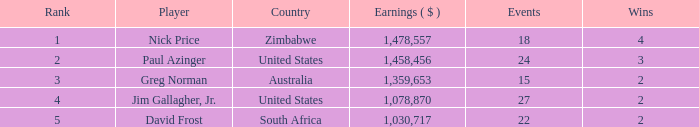How many events have earnings less than 1,030,717? 0.0. Give me the full table as a dictionary. {'header': ['Rank', 'Player', 'Country', 'Earnings ( $ )', 'Events', 'Wins'], 'rows': [['1', 'Nick Price', 'Zimbabwe', '1,478,557', '18', '4'], ['2', 'Paul Azinger', 'United States', '1,458,456', '24', '3'], ['3', 'Greg Norman', 'Australia', '1,359,653', '15', '2'], ['4', 'Jim Gallagher, Jr.', 'United States', '1,078,870', '27', '2'], ['5', 'David Frost', 'South Africa', '1,030,717', '22', '2']]} 